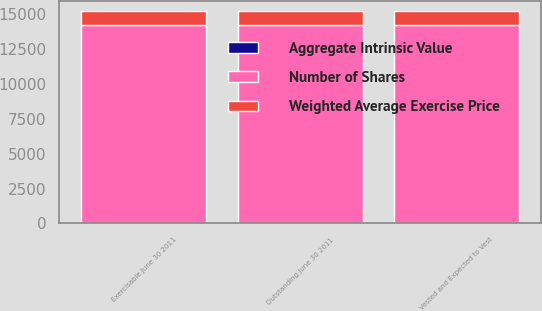Convert chart. <chart><loc_0><loc_0><loc_500><loc_500><stacked_bar_chart><ecel><fcel>Outstanding June 30 2011<fcel>Vested and Expected to Vest<fcel>Exercisable June 30 2011<nl><fcel>Weighted Average Exercise Price<fcel>990<fcel>990<fcel>990<nl><fcel>Aggregate Intrinsic Value<fcel>15.65<fcel>15.65<fcel>15.65<nl><fcel>Number of Shares<fcel>14216<fcel>14216<fcel>14216<nl></chart> 